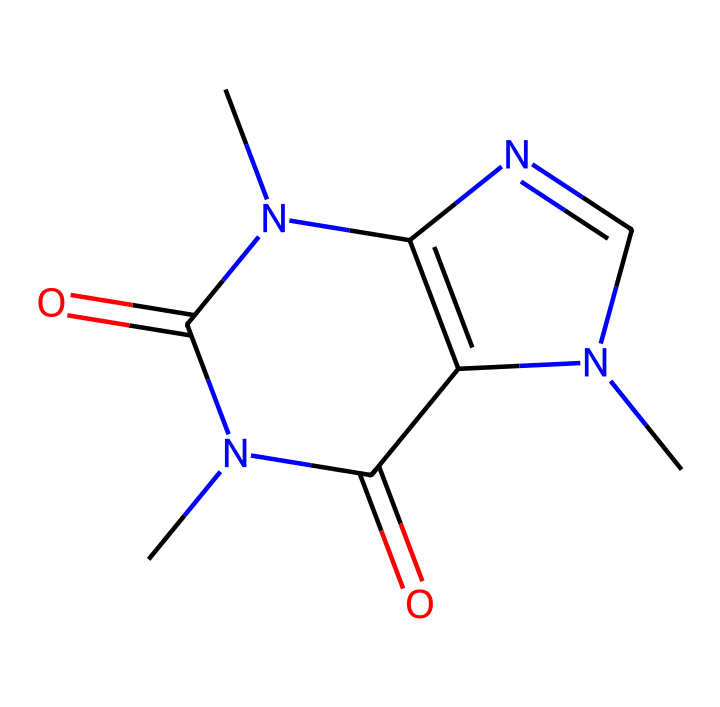What is the molecular formula of caffeine? To determine the molecular formula, we can count the number of each type of atom present in the chemical structure. From the SMILES representation, we have 8 carbon (C), 10 hydrogen (H), 4 nitrogen (N), and 2 oxygen (O) atoms. Therefore, the molecular formula is C8H10N4O2.
Answer: C8H10N4O2 How many nitrogen atoms are present in caffeine? In the SMILES structure, the nitrogen atoms are represented by the letter 'N'. Counting these in the structure shows that there are a total of 4 nitrogen atoms.
Answer: 4 What is the type of functional groups present in caffeine? The caffeine molecule contains several functional groups, primarily imines and amides, indicated by the presence of nitrogen atoms connected to carbon and the carbonyl (C=O) groups. This classification of nitrogen-based functionalities defines its reactivity.
Answer: imines and amides What is the significance of the nitrogen atom in the structure of caffeine? The nitrogen atoms in caffeine contribute to its classification as an alkaloid, which is known for having physiological effects, including stimulation of the central nervous system, thereby highlighting the functional roles of nitrogen in this compound.
Answer: alkaloid How many rings are present in the structure of caffeine? By analyzing the structure through the SMILES, we can identify two ring systems due to the closure of certain carbon and nitrogen atoms forming cyclic structures. Therefore, caffeine contains two rings.
Answer: 2 What type of bonding predominates in the structure of caffeine? The predominant type of bonding in caffeine consists of covalent bonds, where atoms share electron pairs, as indicated by the connections between carbon, nitrogen, and oxygen atoms in the structure.
Answer: covalent bonds 